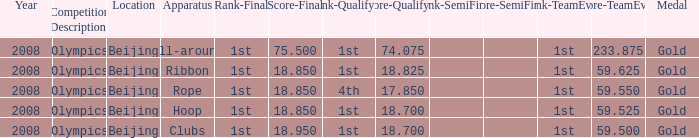What was her lowest final score with a qualifying score of 74.075? 75.5. 